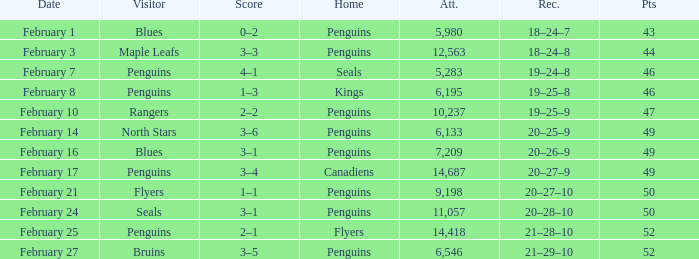Record of 21–29–10 had what total number of points? 1.0. 